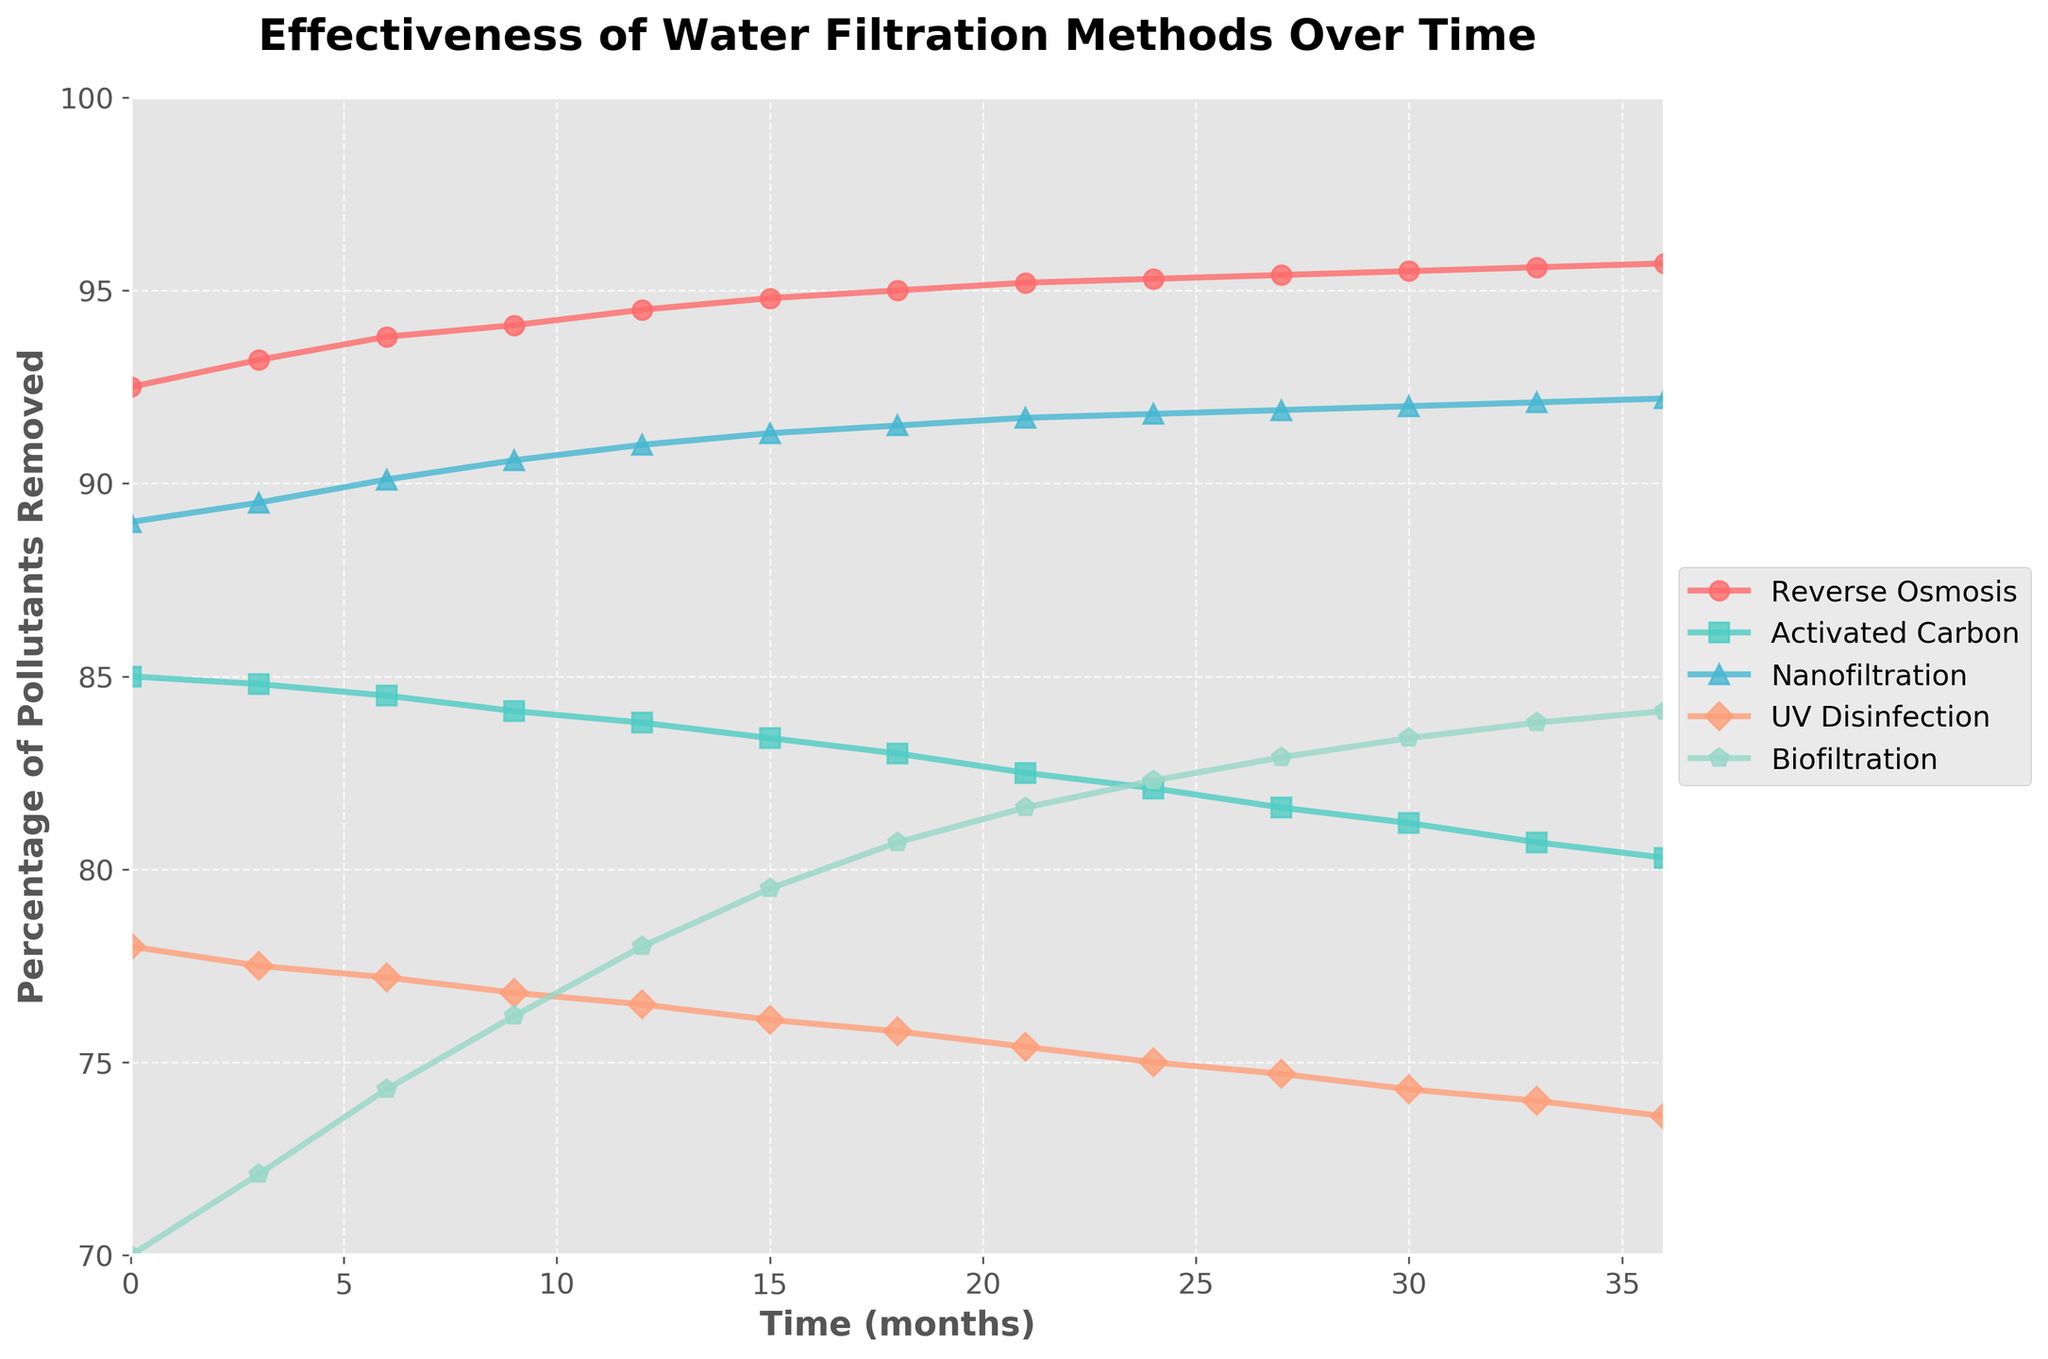How does the effectiveness of Reverse Osmosis change over the first year? Reverse Osmosis starts at 92.5% effectiveness and increases to 94.5% over the first 12 months. This is derived by looking at the data points for Reverse Osmosis at the 0-month (92.5%) and 12-month (94.5%) marks.
Answer: It increases Which method shows the most consistent improvement over time? The method showing the most consistent improvement over time is Biofiltration, which starts at 70.0% and steadily increases to 84.1% at the 36-month mark. This can be observed by comparing the slope and smoothness of the trend lines for each method.
Answer: Biofiltration What is the difference in effectiveness between Nanofiltration and UV Disinfection at the 18-month mark? At 18 months, Nanofiltration is at 91.5% effectiveness, while UV Disinfection is at 75.8%. The difference is calculated as 91.5% - 75.8% = 15.7%.
Answer: 15.7% Which method has the highest initial effectiveness, and what is its value? The method with the highest initial effectiveness is Reverse Osmosis, which starts at 92.5%. This is determined by comparing the starting data points for each method.
Answer: Reverse Osmosis, 92.5% Which method’s effectiveness decreases over time, if any? None of the methods show a decrease in effectiveness over time. All lines either remain constant or increase. This can be observed by examining the slope of each method's trend line.
Answer: None How much does the effectiveness of Activated Carbon decrease from 0 to 36 months? Activated Carbon starts at 85.0% effectiveness and decreases to 80.3% at 36 months. The decrease is calculated as 85.0% - 80.3% = 4.7%.
Answer: 4.7% At which month does Biofiltration surpass 80% effectiveness? Biofiltration surpasses 80% effectiveness at the 18-month mark. This is seen by looking at Biofiltration effectiveness values in the data.
Answer: 18 months What is the average effectiveness of Nanofiltration over the entire time period? To find the average effectiveness, sum all the percentages of Nanofiltration and divide by the number of data points: (89.0 + 89.5 + 90.1 + 90.6 + 91.0 + 91.3 + 91.5 + 91.7 + 91.8 + 91.9 + 92.0 + 92.1 + 92.2) / 13 = 90.97%.
Answer: 90.97% Which two methods are closest in effectiveness at the end of the 36-month period? At the end of 36 months, UV Disinfection (73.6%) and Activated Carbon (80.3%) are closest in effectiveness, with a difference of 80.3% - 73.6% = 6.7%.
Answer: UV Disinfection and Activated Carbon What is the median effectiveness of Biofiltration at all recorded time points? To find the median effectiveness, list all Biofiltration percentages and find the middle value. Sorted values: 70.0, 72.1, 74.3, 76.2, 78.0, 79.5, 80.7, 81.6, 82.3, 82.9, 83.4, 83.8, 84.1. The median is the 7th value: 80.7%.
Answer: 80.7% 